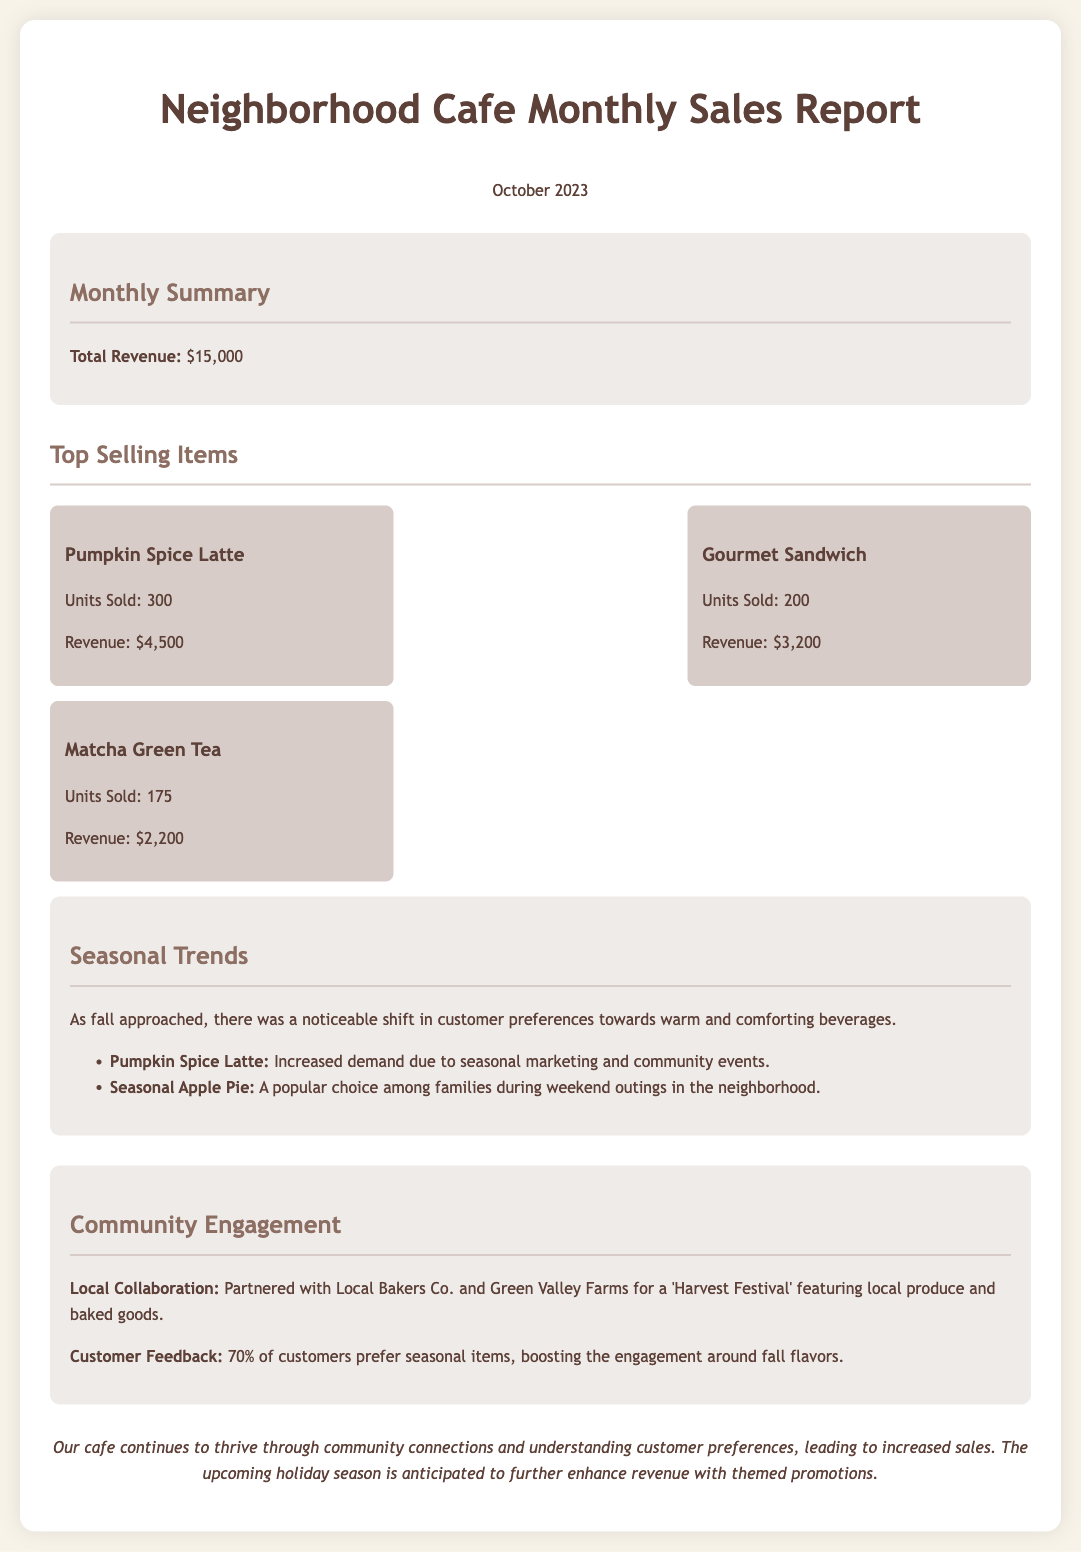What is the total revenue? The total revenue is listed in the summary section of the document as $15,000.
Answer: $15,000 How many Pumpkin Spice Lattes were sold? The number of Pumpkin Spice Lattes sold is mentioned under the top selling items section, which is 300.
Answer: 300 What is the revenue from Gourmet Sandwiches? The revenue from Gourmet Sandwiches is stated in the document as $3,200.
Answer: $3,200 Which item had increased demand due to seasonal marketing? The item with increased demand due to seasonal marketing is the Pumpkin Spice Latte, as noted in the seasonal trends section.
Answer: Pumpkin Spice Latte What percentage of customers prefer seasonal items? The document states that 70% of customers prefer seasonal items.
Answer: 70% What was the popular choice among families during weekend outings? The popular choice mentioned in the seasonal trends section is the Seasonal Apple Pie.
Answer: Seasonal Apple Pie Who did the cafe partner with for the 'Harvest Festival'? The cafe partnered with Local Bakers Co. and Green Valley Farms, as indicated in the community engagement section.
Answer: Local Bakers Co. and Green Valley Farms What seasonal theme is anticipated to enhance revenue further? The document indicates that the upcoming holiday season is expected to enhance revenue with themed promotions.
Answer: Holiday season 